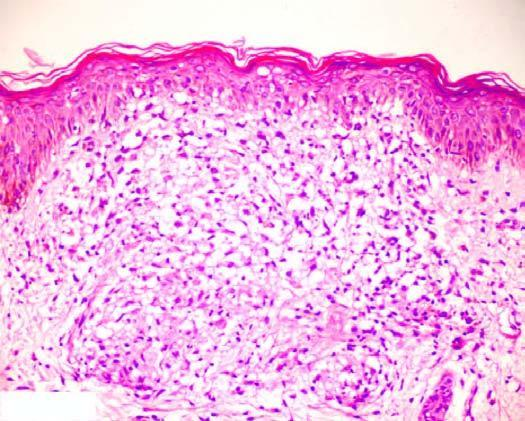what is the granuloma composed of with sparse langhans ' giant cells and lymphocytes?
Answer the question using a single word or phrase. Epithelioid cells with sparse langhans ' giant cells and lymphocytes 